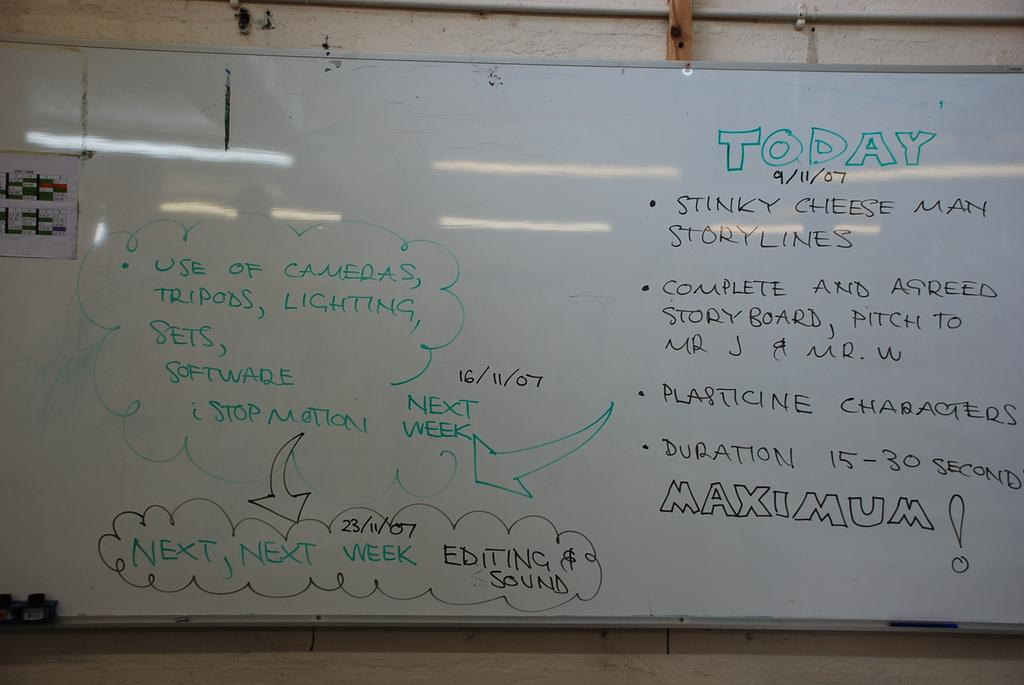<image>
Write a terse but informative summary of the picture. A white board filled with writing and in bold the word Today in green marker 